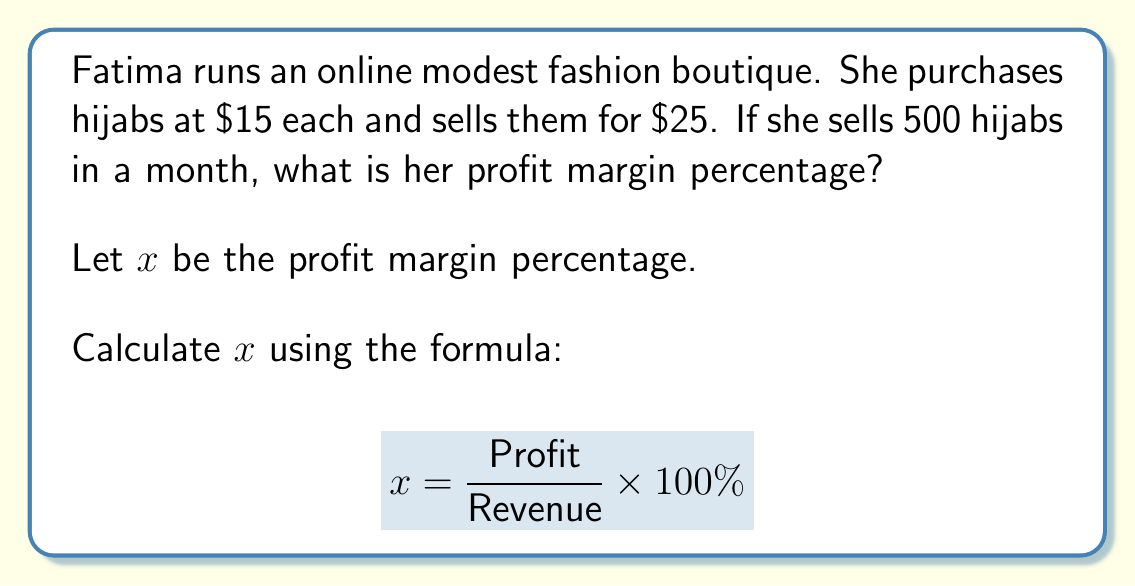Show me your answer to this math problem. To solve this problem, we need to follow these steps:

1. Calculate the revenue:
   Revenue = Selling price × Number of items sold
   $$ \text{Revenue} = \$25 \times 500 = \$12,500 $$

2. Calculate the cost:
   Cost = Purchase price × Number of items sold
   $$ \text{Cost} = \$15 \times 500 = \$7,500 $$

3. Calculate the profit:
   Profit = Revenue - Cost
   $$ \text{Profit} = \$12,500 - \$7,500 = \$5,000 $$

4. Apply the profit margin formula:
   $$ x = \frac{\text{Profit}}{\text{Revenue}} \times 100\% $$
   $$ x = \frac{\$5,000}{\$12,500} \times 100\% $$
   $$ x = 0.4 \times 100\% = 40\% $$

Therefore, Fatima's profit margin percentage is 40%.
Answer: The profit margin percentage is 40%. 